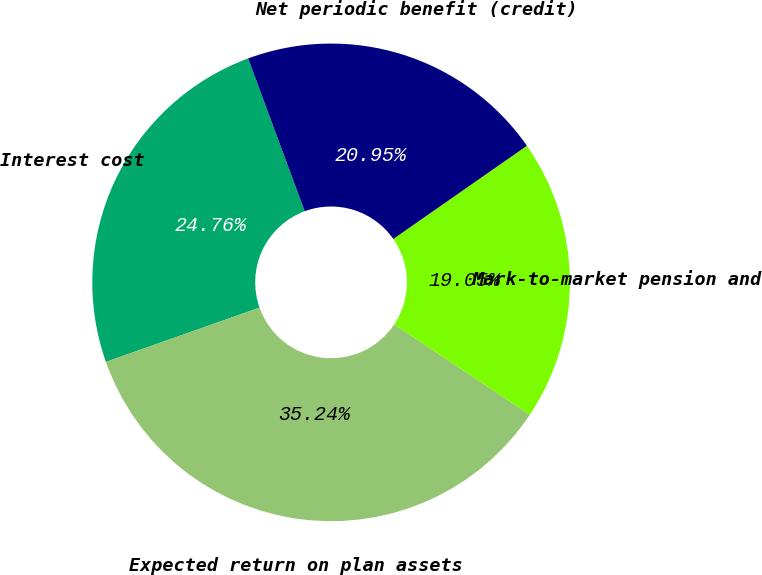Convert chart to OTSL. <chart><loc_0><loc_0><loc_500><loc_500><pie_chart><fcel>Interest cost<fcel>Expected return on plan assets<fcel>Mark-to-market pension and<fcel>Net periodic benefit (credit)<nl><fcel>24.76%<fcel>35.24%<fcel>19.05%<fcel>20.95%<nl></chart> 